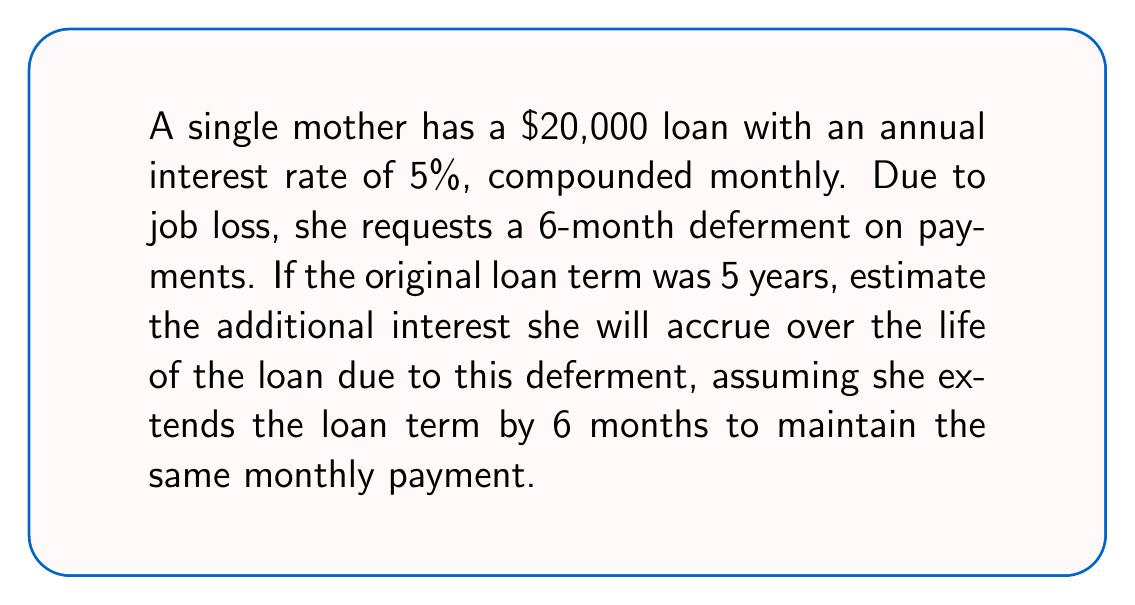Give your solution to this math problem. Let's approach this step-by-step:

1) First, calculate the original monthly payment:
   Using the formula: $P = L\frac{r(1+r)^n}{(1+r)^n-1}$
   Where:
   $L = 20000$ (loan amount)
   $r = \frac{0.05}{12} = 0.004167$ (monthly interest rate)
   $n = 5 * 12 = 60$ (number of monthly payments)

   $P = 20000\frac{0.004167(1+0.004167)^{60}}{(1+0.004167)^{60}-1} \approx 377.42$

2) Calculate total interest paid without deferment:
   Total paid = $377.42 * 60 = 22645.20$
   Total interest = $22645.20 - 20000 = 2645.20$

3) For the deferred scenario, first calculate the balance after 6 months of no payments:
   New balance = $20000(1+0.004167)^6 \approx 20503.77$

4) Now calculate the new monthly payment for the remaining 60 months:
   $P_{new} = 20503.77\frac{0.004167(1+0.004167)^{60}}{(1+0.004167)^{60}-1} \approx 387.25$

5) Calculate total interest paid with deferment:
   Total paid = $387.25 * 60 = 23235.00$
   Total interest = $23235.00 - 20000 = 3235.00$

6) The additional interest due to deferment:
   $3235.00 - 2645.20 = 589.80$
Answer: $589.80 